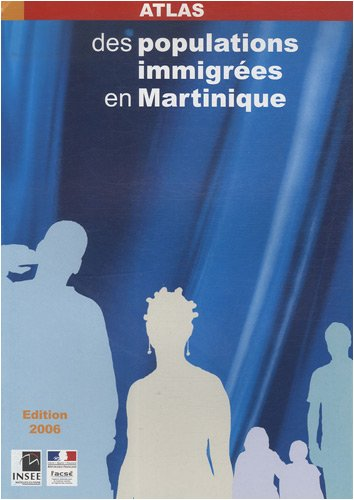Is this book related to Children's Books? This book is not related to children's literature. It is a socio-demographic atlas intended for use by researchers, policymakers, or anyone interested in the details of immigrant populations in Martinique. 